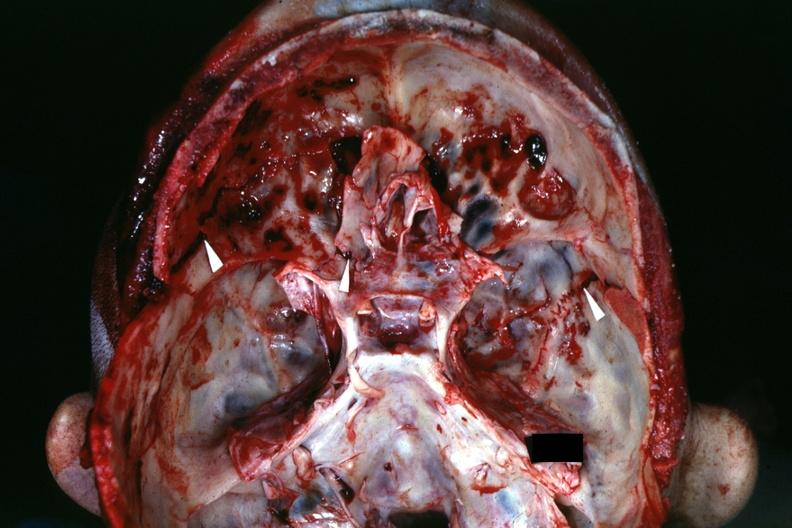what well shown fractures?
Answer the question using a single word or phrase. View of base of skull with several 